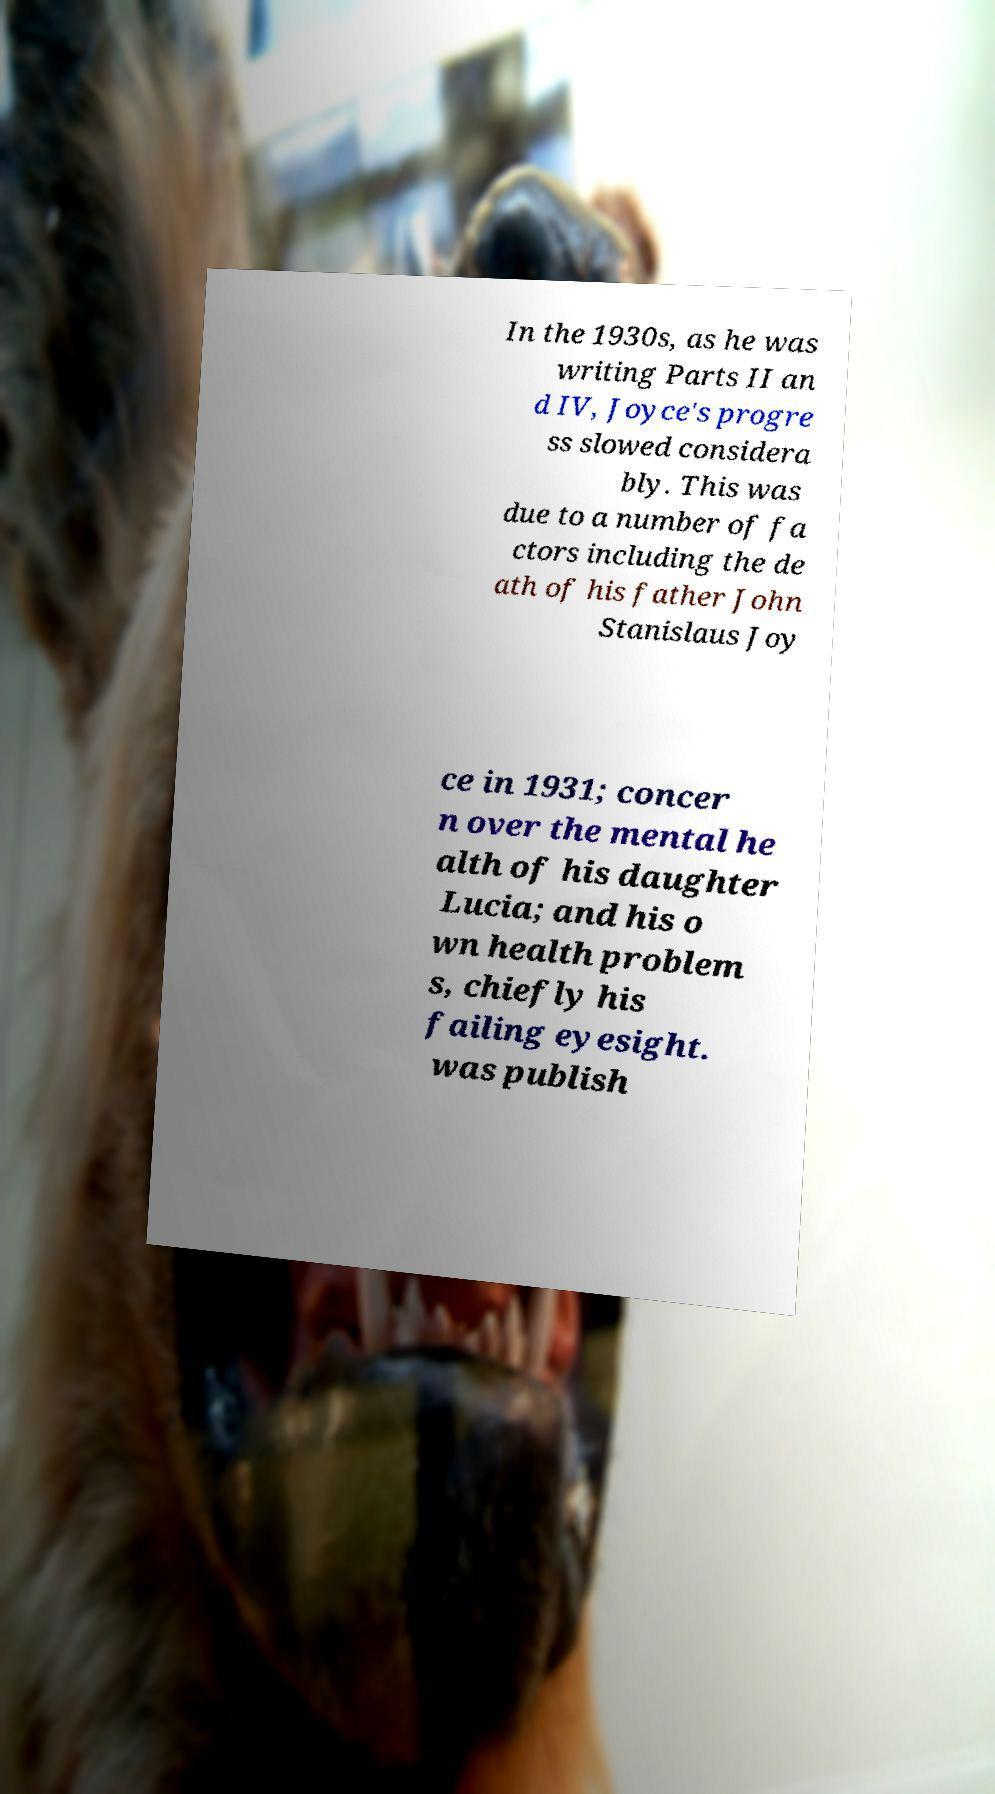Could you assist in decoding the text presented in this image and type it out clearly? In the 1930s, as he was writing Parts II an d IV, Joyce's progre ss slowed considera bly. This was due to a number of fa ctors including the de ath of his father John Stanislaus Joy ce in 1931; concer n over the mental he alth of his daughter Lucia; and his o wn health problem s, chiefly his failing eyesight. was publish 